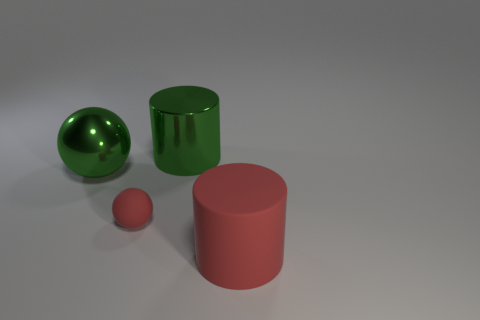Is the number of green metal spheres to the left of the shiny ball the same as the number of large yellow things?
Your answer should be compact. Yes. Do the rubber cylinder and the metal sphere have the same size?
Offer a terse response. Yes. What number of metal things are either large red cylinders or red spheres?
Your answer should be very brief. 0. There is a green cylinder that is the same size as the green ball; what material is it?
Make the answer very short. Metal. What number of other things are made of the same material as the tiny red ball?
Provide a short and direct response. 1. Is the number of cylinders in front of the matte cylinder less than the number of large cylinders?
Provide a succinct answer. Yes. Does the big rubber thing have the same shape as the tiny matte thing?
Your answer should be compact. No. What size is the ball that is in front of the large metal object that is left of the big shiny object that is to the right of the tiny red ball?
Provide a succinct answer. Small. What material is the green thing that is the same shape as the small red thing?
Keep it short and to the point. Metal. Are there any other things that are the same size as the rubber sphere?
Offer a very short reply. No. 